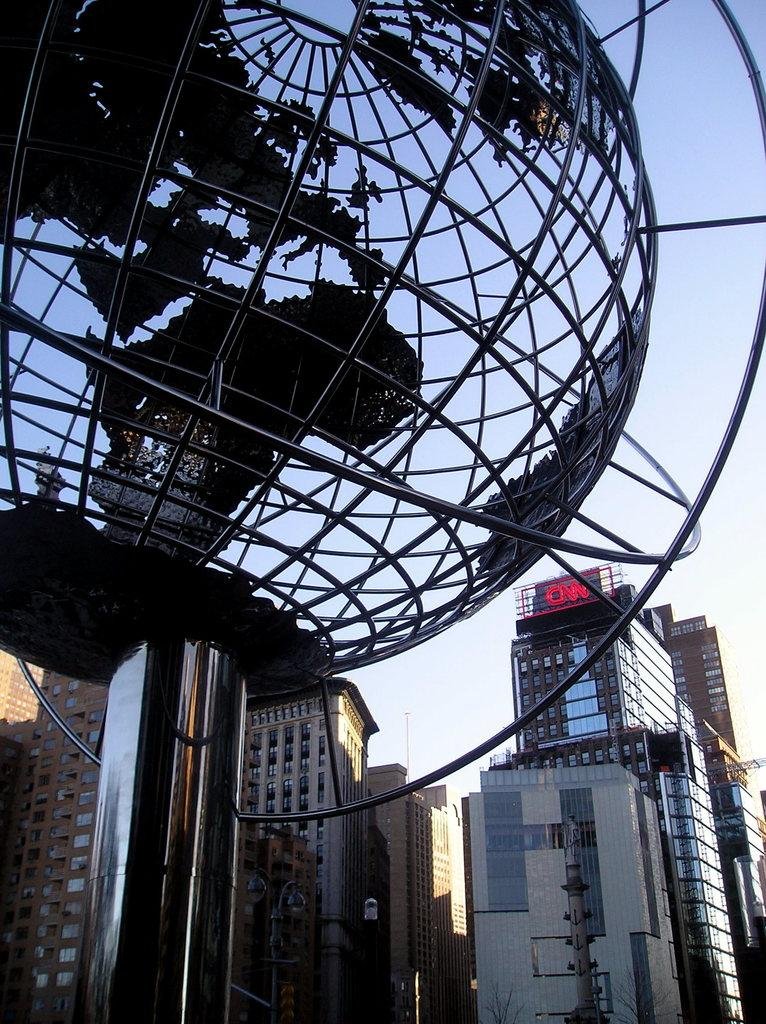What is the main subject of the image? The main subject of the image is a statue of a globe. What can be seen behind the statue in the image? There are many buildings behind the statue in the image. How many legs does the statue of the globe have in the image? The statue of the globe is a representation of a sphere and does not have legs. 